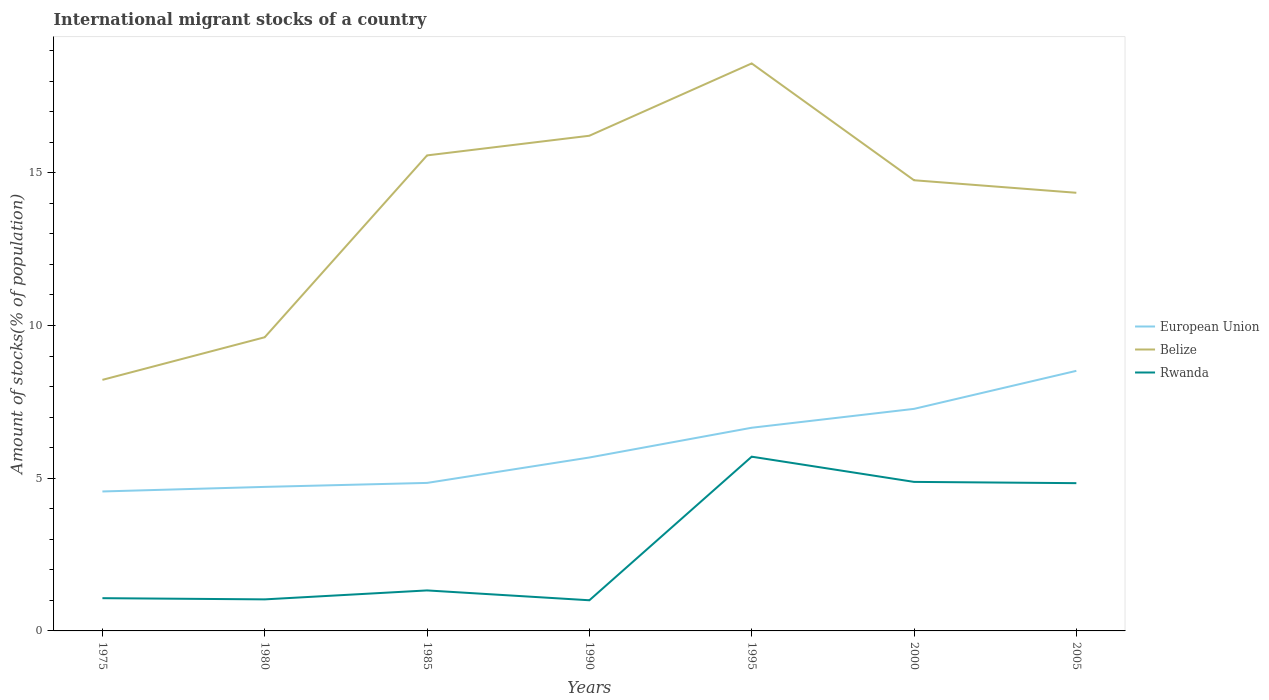How many different coloured lines are there?
Provide a succinct answer. 3. Across all years, what is the maximum amount of stocks in in Rwanda?
Your response must be concise. 1. In which year was the amount of stocks in in Belize maximum?
Provide a short and direct response. 1975. What is the total amount of stocks in in European Union in the graph?
Provide a succinct answer. -0.96. What is the difference between the highest and the second highest amount of stocks in in European Union?
Provide a short and direct response. 3.95. What is the difference between the highest and the lowest amount of stocks in in Belize?
Make the answer very short. 5. Is the amount of stocks in in European Union strictly greater than the amount of stocks in in Rwanda over the years?
Your answer should be very brief. No. How many years are there in the graph?
Make the answer very short. 7. What is the difference between two consecutive major ticks on the Y-axis?
Make the answer very short. 5. Does the graph contain grids?
Your answer should be very brief. No. How are the legend labels stacked?
Your response must be concise. Vertical. What is the title of the graph?
Offer a very short reply. International migrant stocks of a country. Does "Costa Rica" appear as one of the legend labels in the graph?
Your answer should be very brief. No. What is the label or title of the X-axis?
Provide a succinct answer. Years. What is the label or title of the Y-axis?
Offer a very short reply. Amount of stocks(% of population). What is the Amount of stocks(% of population) of European Union in 1975?
Provide a succinct answer. 4.57. What is the Amount of stocks(% of population) in Belize in 1975?
Your response must be concise. 8.22. What is the Amount of stocks(% of population) in Rwanda in 1975?
Offer a very short reply. 1.07. What is the Amount of stocks(% of population) of European Union in 1980?
Keep it short and to the point. 4.72. What is the Amount of stocks(% of population) in Belize in 1980?
Offer a terse response. 9.61. What is the Amount of stocks(% of population) of Rwanda in 1980?
Give a very brief answer. 1.03. What is the Amount of stocks(% of population) of European Union in 1985?
Ensure brevity in your answer.  4.85. What is the Amount of stocks(% of population) in Belize in 1985?
Provide a short and direct response. 15.57. What is the Amount of stocks(% of population) of Rwanda in 1985?
Offer a terse response. 1.33. What is the Amount of stocks(% of population) in European Union in 1990?
Offer a very short reply. 5.68. What is the Amount of stocks(% of population) in Belize in 1990?
Offer a very short reply. 16.21. What is the Amount of stocks(% of population) in Rwanda in 1990?
Keep it short and to the point. 1. What is the Amount of stocks(% of population) in European Union in 1995?
Provide a succinct answer. 6.65. What is the Amount of stocks(% of population) of Belize in 1995?
Provide a succinct answer. 18.58. What is the Amount of stocks(% of population) of Rwanda in 1995?
Offer a terse response. 5.7. What is the Amount of stocks(% of population) in European Union in 2000?
Ensure brevity in your answer.  7.27. What is the Amount of stocks(% of population) of Belize in 2000?
Offer a very short reply. 14.75. What is the Amount of stocks(% of population) in Rwanda in 2000?
Give a very brief answer. 4.88. What is the Amount of stocks(% of population) in European Union in 2005?
Ensure brevity in your answer.  8.51. What is the Amount of stocks(% of population) of Belize in 2005?
Give a very brief answer. 14.34. What is the Amount of stocks(% of population) of Rwanda in 2005?
Your answer should be very brief. 4.84. Across all years, what is the maximum Amount of stocks(% of population) in European Union?
Ensure brevity in your answer.  8.51. Across all years, what is the maximum Amount of stocks(% of population) of Belize?
Give a very brief answer. 18.58. Across all years, what is the maximum Amount of stocks(% of population) of Rwanda?
Offer a terse response. 5.7. Across all years, what is the minimum Amount of stocks(% of population) in European Union?
Your answer should be very brief. 4.57. Across all years, what is the minimum Amount of stocks(% of population) in Belize?
Make the answer very short. 8.22. Across all years, what is the minimum Amount of stocks(% of population) of Rwanda?
Your answer should be very brief. 1. What is the total Amount of stocks(% of population) in European Union in the graph?
Your answer should be compact. 42.24. What is the total Amount of stocks(% of population) in Belize in the graph?
Offer a terse response. 97.29. What is the total Amount of stocks(% of population) of Rwanda in the graph?
Your answer should be compact. 19.85. What is the difference between the Amount of stocks(% of population) of European Union in 1975 and that in 1980?
Offer a very short reply. -0.15. What is the difference between the Amount of stocks(% of population) of Belize in 1975 and that in 1980?
Make the answer very short. -1.4. What is the difference between the Amount of stocks(% of population) in Rwanda in 1975 and that in 1980?
Ensure brevity in your answer.  0.04. What is the difference between the Amount of stocks(% of population) in European Union in 1975 and that in 1985?
Your answer should be very brief. -0.28. What is the difference between the Amount of stocks(% of population) of Belize in 1975 and that in 1985?
Offer a very short reply. -7.35. What is the difference between the Amount of stocks(% of population) of Rwanda in 1975 and that in 1985?
Make the answer very short. -0.25. What is the difference between the Amount of stocks(% of population) in European Union in 1975 and that in 1990?
Your response must be concise. -1.11. What is the difference between the Amount of stocks(% of population) of Belize in 1975 and that in 1990?
Offer a terse response. -7.99. What is the difference between the Amount of stocks(% of population) in Rwanda in 1975 and that in 1990?
Your answer should be compact. 0.07. What is the difference between the Amount of stocks(% of population) of European Union in 1975 and that in 1995?
Make the answer very short. -2.09. What is the difference between the Amount of stocks(% of population) of Belize in 1975 and that in 1995?
Offer a terse response. -10.36. What is the difference between the Amount of stocks(% of population) of Rwanda in 1975 and that in 1995?
Make the answer very short. -4.63. What is the difference between the Amount of stocks(% of population) in European Union in 1975 and that in 2000?
Your answer should be very brief. -2.7. What is the difference between the Amount of stocks(% of population) in Belize in 1975 and that in 2000?
Provide a short and direct response. -6.53. What is the difference between the Amount of stocks(% of population) of Rwanda in 1975 and that in 2000?
Make the answer very short. -3.81. What is the difference between the Amount of stocks(% of population) in European Union in 1975 and that in 2005?
Make the answer very short. -3.95. What is the difference between the Amount of stocks(% of population) of Belize in 1975 and that in 2005?
Offer a terse response. -6.12. What is the difference between the Amount of stocks(% of population) in Rwanda in 1975 and that in 2005?
Make the answer very short. -3.77. What is the difference between the Amount of stocks(% of population) of European Union in 1980 and that in 1985?
Your answer should be very brief. -0.13. What is the difference between the Amount of stocks(% of population) of Belize in 1980 and that in 1985?
Your response must be concise. -5.95. What is the difference between the Amount of stocks(% of population) of Rwanda in 1980 and that in 1985?
Provide a succinct answer. -0.29. What is the difference between the Amount of stocks(% of population) in European Union in 1980 and that in 1990?
Give a very brief answer. -0.96. What is the difference between the Amount of stocks(% of population) of Belize in 1980 and that in 1990?
Provide a short and direct response. -6.6. What is the difference between the Amount of stocks(% of population) of Rwanda in 1980 and that in 1990?
Make the answer very short. 0.03. What is the difference between the Amount of stocks(% of population) of European Union in 1980 and that in 1995?
Keep it short and to the point. -1.94. What is the difference between the Amount of stocks(% of population) in Belize in 1980 and that in 1995?
Make the answer very short. -8.96. What is the difference between the Amount of stocks(% of population) of Rwanda in 1980 and that in 1995?
Your answer should be compact. -4.67. What is the difference between the Amount of stocks(% of population) in European Union in 1980 and that in 2000?
Give a very brief answer. -2.55. What is the difference between the Amount of stocks(% of population) in Belize in 1980 and that in 2000?
Provide a succinct answer. -5.14. What is the difference between the Amount of stocks(% of population) of Rwanda in 1980 and that in 2000?
Give a very brief answer. -3.85. What is the difference between the Amount of stocks(% of population) of European Union in 1980 and that in 2005?
Offer a very short reply. -3.8. What is the difference between the Amount of stocks(% of population) in Belize in 1980 and that in 2005?
Offer a terse response. -4.73. What is the difference between the Amount of stocks(% of population) in Rwanda in 1980 and that in 2005?
Give a very brief answer. -3.8. What is the difference between the Amount of stocks(% of population) of European Union in 1985 and that in 1990?
Provide a short and direct response. -0.83. What is the difference between the Amount of stocks(% of population) in Belize in 1985 and that in 1990?
Your answer should be compact. -0.64. What is the difference between the Amount of stocks(% of population) in Rwanda in 1985 and that in 1990?
Provide a succinct answer. 0.32. What is the difference between the Amount of stocks(% of population) in European Union in 1985 and that in 1995?
Provide a short and direct response. -1.81. What is the difference between the Amount of stocks(% of population) in Belize in 1985 and that in 1995?
Provide a short and direct response. -3.01. What is the difference between the Amount of stocks(% of population) of Rwanda in 1985 and that in 1995?
Your answer should be very brief. -4.38. What is the difference between the Amount of stocks(% of population) of European Union in 1985 and that in 2000?
Provide a succinct answer. -2.42. What is the difference between the Amount of stocks(% of population) in Belize in 1985 and that in 2000?
Make the answer very short. 0.81. What is the difference between the Amount of stocks(% of population) of Rwanda in 1985 and that in 2000?
Keep it short and to the point. -3.55. What is the difference between the Amount of stocks(% of population) of European Union in 1985 and that in 2005?
Your answer should be compact. -3.67. What is the difference between the Amount of stocks(% of population) of Belize in 1985 and that in 2005?
Offer a terse response. 1.22. What is the difference between the Amount of stocks(% of population) of Rwanda in 1985 and that in 2005?
Offer a very short reply. -3.51. What is the difference between the Amount of stocks(% of population) of European Union in 1990 and that in 1995?
Give a very brief answer. -0.97. What is the difference between the Amount of stocks(% of population) of Belize in 1990 and that in 1995?
Give a very brief answer. -2.37. What is the difference between the Amount of stocks(% of population) in Rwanda in 1990 and that in 1995?
Offer a very short reply. -4.7. What is the difference between the Amount of stocks(% of population) of European Union in 1990 and that in 2000?
Offer a terse response. -1.59. What is the difference between the Amount of stocks(% of population) of Belize in 1990 and that in 2000?
Provide a succinct answer. 1.46. What is the difference between the Amount of stocks(% of population) in Rwanda in 1990 and that in 2000?
Provide a succinct answer. -3.88. What is the difference between the Amount of stocks(% of population) of European Union in 1990 and that in 2005?
Your response must be concise. -2.84. What is the difference between the Amount of stocks(% of population) of Belize in 1990 and that in 2005?
Your answer should be compact. 1.87. What is the difference between the Amount of stocks(% of population) of Rwanda in 1990 and that in 2005?
Provide a succinct answer. -3.83. What is the difference between the Amount of stocks(% of population) of European Union in 1995 and that in 2000?
Keep it short and to the point. -0.62. What is the difference between the Amount of stocks(% of population) of Belize in 1995 and that in 2000?
Make the answer very short. 3.82. What is the difference between the Amount of stocks(% of population) in Rwanda in 1995 and that in 2000?
Keep it short and to the point. 0.83. What is the difference between the Amount of stocks(% of population) in European Union in 1995 and that in 2005?
Your response must be concise. -1.86. What is the difference between the Amount of stocks(% of population) in Belize in 1995 and that in 2005?
Ensure brevity in your answer.  4.24. What is the difference between the Amount of stocks(% of population) of Rwanda in 1995 and that in 2005?
Make the answer very short. 0.87. What is the difference between the Amount of stocks(% of population) in European Union in 2000 and that in 2005?
Your answer should be very brief. -1.25. What is the difference between the Amount of stocks(% of population) in Belize in 2000 and that in 2005?
Make the answer very short. 0.41. What is the difference between the Amount of stocks(% of population) in Rwanda in 2000 and that in 2005?
Keep it short and to the point. 0.04. What is the difference between the Amount of stocks(% of population) in European Union in 1975 and the Amount of stocks(% of population) in Belize in 1980?
Provide a short and direct response. -5.05. What is the difference between the Amount of stocks(% of population) in European Union in 1975 and the Amount of stocks(% of population) in Rwanda in 1980?
Give a very brief answer. 3.53. What is the difference between the Amount of stocks(% of population) in Belize in 1975 and the Amount of stocks(% of population) in Rwanda in 1980?
Offer a very short reply. 7.19. What is the difference between the Amount of stocks(% of population) in European Union in 1975 and the Amount of stocks(% of population) in Belize in 1985?
Your answer should be compact. -11. What is the difference between the Amount of stocks(% of population) in European Union in 1975 and the Amount of stocks(% of population) in Rwanda in 1985?
Make the answer very short. 3.24. What is the difference between the Amount of stocks(% of population) in Belize in 1975 and the Amount of stocks(% of population) in Rwanda in 1985?
Offer a very short reply. 6.89. What is the difference between the Amount of stocks(% of population) in European Union in 1975 and the Amount of stocks(% of population) in Belize in 1990?
Your response must be concise. -11.65. What is the difference between the Amount of stocks(% of population) in European Union in 1975 and the Amount of stocks(% of population) in Rwanda in 1990?
Your answer should be very brief. 3.56. What is the difference between the Amount of stocks(% of population) of Belize in 1975 and the Amount of stocks(% of population) of Rwanda in 1990?
Your answer should be compact. 7.22. What is the difference between the Amount of stocks(% of population) in European Union in 1975 and the Amount of stocks(% of population) in Belize in 1995?
Provide a succinct answer. -14.01. What is the difference between the Amount of stocks(% of population) in European Union in 1975 and the Amount of stocks(% of population) in Rwanda in 1995?
Give a very brief answer. -1.14. What is the difference between the Amount of stocks(% of population) in Belize in 1975 and the Amount of stocks(% of population) in Rwanda in 1995?
Ensure brevity in your answer.  2.51. What is the difference between the Amount of stocks(% of population) of European Union in 1975 and the Amount of stocks(% of population) of Belize in 2000?
Your answer should be compact. -10.19. What is the difference between the Amount of stocks(% of population) in European Union in 1975 and the Amount of stocks(% of population) in Rwanda in 2000?
Your answer should be very brief. -0.31. What is the difference between the Amount of stocks(% of population) in Belize in 1975 and the Amount of stocks(% of population) in Rwanda in 2000?
Make the answer very short. 3.34. What is the difference between the Amount of stocks(% of population) in European Union in 1975 and the Amount of stocks(% of population) in Belize in 2005?
Provide a short and direct response. -9.78. What is the difference between the Amount of stocks(% of population) of European Union in 1975 and the Amount of stocks(% of population) of Rwanda in 2005?
Make the answer very short. -0.27. What is the difference between the Amount of stocks(% of population) in Belize in 1975 and the Amount of stocks(% of population) in Rwanda in 2005?
Provide a succinct answer. 3.38. What is the difference between the Amount of stocks(% of population) in European Union in 1980 and the Amount of stocks(% of population) in Belize in 1985?
Your response must be concise. -10.85. What is the difference between the Amount of stocks(% of population) of European Union in 1980 and the Amount of stocks(% of population) of Rwanda in 1985?
Your response must be concise. 3.39. What is the difference between the Amount of stocks(% of population) in Belize in 1980 and the Amount of stocks(% of population) in Rwanda in 1985?
Your response must be concise. 8.29. What is the difference between the Amount of stocks(% of population) in European Union in 1980 and the Amount of stocks(% of population) in Belize in 1990?
Provide a short and direct response. -11.5. What is the difference between the Amount of stocks(% of population) in European Union in 1980 and the Amount of stocks(% of population) in Rwanda in 1990?
Provide a succinct answer. 3.71. What is the difference between the Amount of stocks(% of population) in Belize in 1980 and the Amount of stocks(% of population) in Rwanda in 1990?
Offer a very short reply. 8.61. What is the difference between the Amount of stocks(% of population) in European Union in 1980 and the Amount of stocks(% of population) in Belize in 1995?
Give a very brief answer. -13.86. What is the difference between the Amount of stocks(% of population) of European Union in 1980 and the Amount of stocks(% of population) of Rwanda in 1995?
Provide a short and direct response. -0.99. What is the difference between the Amount of stocks(% of population) in Belize in 1980 and the Amount of stocks(% of population) in Rwanda in 1995?
Your answer should be compact. 3.91. What is the difference between the Amount of stocks(% of population) in European Union in 1980 and the Amount of stocks(% of population) in Belize in 2000?
Provide a short and direct response. -10.04. What is the difference between the Amount of stocks(% of population) of European Union in 1980 and the Amount of stocks(% of population) of Rwanda in 2000?
Offer a terse response. -0.16. What is the difference between the Amount of stocks(% of population) of Belize in 1980 and the Amount of stocks(% of population) of Rwanda in 2000?
Give a very brief answer. 4.74. What is the difference between the Amount of stocks(% of population) of European Union in 1980 and the Amount of stocks(% of population) of Belize in 2005?
Offer a terse response. -9.63. What is the difference between the Amount of stocks(% of population) of European Union in 1980 and the Amount of stocks(% of population) of Rwanda in 2005?
Your response must be concise. -0.12. What is the difference between the Amount of stocks(% of population) of Belize in 1980 and the Amount of stocks(% of population) of Rwanda in 2005?
Offer a very short reply. 4.78. What is the difference between the Amount of stocks(% of population) of European Union in 1985 and the Amount of stocks(% of population) of Belize in 1990?
Ensure brevity in your answer.  -11.37. What is the difference between the Amount of stocks(% of population) of European Union in 1985 and the Amount of stocks(% of population) of Rwanda in 1990?
Make the answer very short. 3.84. What is the difference between the Amount of stocks(% of population) of Belize in 1985 and the Amount of stocks(% of population) of Rwanda in 1990?
Your answer should be very brief. 14.56. What is the difference between the Amount of stocks(% of population) of European Union in 1985 and the Amount of stocks(% of population) of Belize in 1995?
Offer a very short reply. -13.73. What is the difference between the Amount of stocks(% of population) in European Union in 1985 and the Amount of stocks(% of population) in Rwanda in 1995?
Ensure brevity in your answer.  -0.86. What is the difference between the Amount of stocks(% of population) in Belize in 1985 and the Amount of stocks(% of population) in Rwanda in 1995?
Your answer should be compact. 9.86. What is the difference between the Amount of stocks(% of population) in European Union in 1985 and the Amount of stocks(% of population) in Belize in 2000?
Provide a succinct answer. -9.91. What is the difference between the Amount of stocks(% of population) in European Union in 1985 and the Amount of stocks(% of population) in Rwanda in 2000?
Offer a very short reply. -0.03. What is the difference between the Amount of stocks(% of population) in Belize in 1985 and the Amount of stocks(% of population) in Rwanda in 2000?
Offer a terse response. 10.69. What is the difference between the Amount of stocks(% of population) in European Union in 1985 and the Amount of stocks(% of population) in Belize in 2005?
Your answer should be compact. -9.5. What is the difference between the Amount of stocks(% of population) of European Union in 1985 and the Amount of stocks(% of population) of Rwanda in 2005?
Give a very brief answer. 0.01. What is the difference between the Amount of stocks(% of population) of Belize in 1985 and the Amount of stocks(% of population) of Rwanda in 2005?
Provide a short and direct response. 10.73. What is the difference between the Amount of stocks(% of population) in European Union in 1990 and the Amount of stocks(% of population) in Belize in 1995?
Make the answer very short. -12.9. What is the difference between the Amount of stocks(% of population) of European Union in 1990 and the Amount of stocks(% of population) of Rwanda in 1995?
Make the answer very short. -0.03. What is the difference between the Amount of stocks(% of population) of Belize in 1990 and the Amount of stocks(% of population) of Rwanda in 1995?
Provide a succinct answer. 10.51. What is the difference between the Amount of stocks(% of population) of European Union in 1990 and the Amount of stocks(% of population) of Belize in 2000?
Provide a short and direct response. -9.08. What is the difference between the Amount of stocks(% of population) in European Union in 1990 and the Amount of stocks(% of population) in Rwanda in 2000?
Provide a short and direct response. 0.8. What is the difference between the Amount of stocks(% of population) of Belize in 1990 and the Amount of stocks(% of population) of Rwanda in 2000?
Give a very brief answer. 11.33. What is the difference between the Amount of stocks(% of population) in European Union in 1990 and the Amount of stocks(% of population) in Belize in 2005?
Give a very brief answer. -8.67. What is the difference between the Amount of stocks(% of population) of European Union in 1990 and the Amount of stocks(% of population) of Rwanda in 2005?
Your answer should be very brief. 0.84. What is the difference between the Amount of stocks(% of population) in Belize in 1990 and the Amount of stocks(% of population) in Rwanda in 2005?
Ensure brevity in your answer.  11.37. What is the difference between the Amount of stocks(% of population) in European Union in 1995 and the Amount of stocks(% of population) in Belize in 2000?
Provide a succinct answer. -8.1. What is the difference between the Amount of stocks(% of population) in European Union in 1995 and the Amount of stocks(% of population) in Rwanda in 2000?
Your response must be concise. 1.77. What is the difference between the Amount of stocks(% of population) of Belize in 1995 and the Amount of stocks(% of population) of Rwanda in 2000?
Offer a very short reply. 13.7. What is the difference between the Amount of stocks(% of population) in European Union in 1995 and the Amount of stocks(% of population) in Belize in 2005?
Give a very brief answer. -7.69. What is the difference between the Amount of stocks(% of population) in European Union in 1995 and the Amount of stocks(% of population) in Rwanda in 2005?
Offer a very short reply. 1.81. What is the difference between the Amount of stocks(% of population) in Belize in 1995 and the Amount of stocks(% of population) in Rwanda in 2005?
Provide a succinct answer. 13.74. What is the difference between the Amount of stocks(% of population) in European Union in 2000 and the Amount of stocks(% of population) in Belize in 2005?
Provide a short and direct response. -7.07. What is the difference between the Amount of stocks(% of population) of European Union in 2000 and the Amount of stocks(% of population) of Rwanda in 2005?
Your answer should be compact. 2.43. What is the difference between the Amount of stocks(% of population) in Belize in 2000 and the Amount of stocks(% of population) in Rwanda in 2005?
Give a very brief answer. 9.92. What is the average Amount of stocks(% of population) in European Union per year?
Ensure brevity in your answer.  6.03. What is the average Amount of stocks(% of population) in Belize per year?
Provide a short and direct response. 13.9. What is the average Amount of stocks(% of population) in Rwanda per year?
Give a very brief answer. 2.84. In the year 1975, what is the difference between the Amount of stocks(% of population) in European Union and Amount of stocks(% of population) in Belize?
Provide a short and direct response. -3.65. In the year 1975, what is the difference between the Amount of stocks(% of population) of European Union and Amount of stocks(% of population) of Rwanda?
Offer a terse response. 3.49. In the year 1975, what is the difference between the Amount of stocks(% of population) of Belize and Amount of stocks(% of population) of Rwanda?
Ensure brevity in your answer.  7.15. In the year 1980, what is the difference between the Amount of stocks(% of population) in European Union and Amount of stocks(% of population) in Belize?
Offer a very short reply. -4.9. In the year 1980, what is the difference between the Amount of stocks(% of population) of European Union and Amount of stocks(% of population) of Rwanda?
Your answer should be compact. 3.68. In the year 1980, what is the difference between the Amount of stocks(% of population) of Belize and Amount of stocks(% of population) of Rwanda?
Provide a succinct answer. 8.58. In the year 1985, what is the difference between the Amount of stocks(% of population) of European Union and Amount of stocks(% of population) of Belize?
Keep it short and to the point. -10.72. In the year 1985, what is the difference between the Amount of stocks(% of population) in European Union and Amount of stocks(% of population) in Rwanda?
Your response must be concise. 3.52. In the year 1985, what is the difference between the Amount of stocks(% of population) of Belize and Amount of stocks(% of population) of Rwanda?
Give a very brief answer. 14.24. In the year 1990, what is the difference between the Amount of stocks(% of population) in European Union and Amount of stocks(% of population) in Belize?
Offer a very short reply. -10.53. In the year 1990, what is the difference between the Amount of stocks(% of population) in European Union and Amount of stocks(% of population) in Rwanda?
Give a very brief answer. 4.67. In the year 1990, what is the difference between the Amount of stocks(% of population) in Belize and Amount of stocks(% of population) in Rwanda?
Offer a very short reply. 15.21. In the year 1995, what is the difference between the Amount of stocks(% of population) in European Union and Amount of stocks(% of population) in Belize?
Give a very brief answer. -11.93. In the year 1995, what is the difference between the Amount of stocks(% of population) of European Union and Amount of stocks(% of population) of Rwanda?
Your answer should be very brief. 0.95. In the year 1995, what is the difference between the Amount of stocks(% of population) in Belize and Amount of stocks(% of population) in Rwanda?
Make the answer very short. 12.87. In the year 2000, what is the difference between the Amount of stocks(% of population) in European Union and Amount of stocks(% of population) in Belize?
Offer a terse response. -7.48. In the year 2000, what is the difference between the Amount of stocks(% of population) of European Union and Amount of stocks(% of population) of Rwanda?
Your answer should be compact. 2.39. In the year 2000, what is the difference between the Amount of stocks(% of population) of Belize and Amount of stocks(% of population) of Rwanda?
Make the answer very short. 9.87. In the year 2005, what is the difference between the Amount of stocks(% of population) of European Union and Amount of stocks(% of population) of Belize?
Your response must be concise. -5.83. In the year 2005, what is the difference between the Amount of stocks(% of population) of European Union and Amount of stocks(% of population) of Rwanda?
Provide a succinct answer. 3.68. In the year 2005, what is the difference between the Amount of stocks(% of population) in Belize and Amount of stocks(% of population) in Rwanda?
Your answer should be very brief. 9.51. What is the ratio of the Amount of stocks(% of population) in European Union in 1975 to that in 1980?
Give a very brief answer. 0.97. What is the ratio of the Amount of stocks(% of population) of Belize in 1975 to that in 1980?
Your answer should be very brief. 0.85. What is the ratio of the Amount of stocks(% of population) of Rwanda in 1975 to that in 1980?
Your answer should be very brief. 1.04. What is the ratio of the Amount of stocks(% of population) in European Union in 1975 to that in 1985?
Keep it short and to the point. 0.94. What is the ratio of the Amount of stocks(% of population) of Belize in 1975 to that in 1985?
Give a very brief answer. 0.53. What is the ratio of the Amount of stocks(% of population) in Rwanda in 1975 to that in 1985?
Make the answer very short. 0.81. What is the ratio of the Amount of stocks(% of population) in European Union in 1975 to that in 1990?
Provide a short and direct response. 0.8. What is the ratio of the Amount of stocks(% of population) of Belize in 1975 to that in 1990?
Make the answer very short. 0.51. What is the ratio of the Amount of stocks(% of population) of Rwanda in 1975 to that in 1990?
Ensure brevity in your answer.  1.07. What is the ratio of the Amount of stocks(% of population) of European Union in 1975 to that in 1995?
Provide a succinct answer. 0.69. What is the ratio of the Amount of stocks(% of population) of Belize in 1975 to that in 1995?
Give a very brief answer. 0.44. What is the ratio of the Amount of stocks(% of population) of Rwanda in 1975 to that in 1995?
Ensure brevity in your answer.  0.19. What is the ratio of the Amount of stocks(% of population) in European Union in 1975 to that in 2000?
Provide a short and direct response. 0.63. What is the ratio of the Amount of stocks(% of population) in Belize in 1975 to that in 2000?
Offer a terse response. 0.56. What is the ratio of the Amount of stocks(% of population) of Rwanda in 1975 to that in 2000?
Your answer should be compact. 0.22. What is the ratio of the Amount of stocks(% of population) in European Union in 1975 to that in 2005?
Offer a terse response. 0.54. What is the ratio of the Amount of stocks(% of population) of Belize in 1975 to that in 2005?
Your answer should be very brief. 0.57. What is the ratio of the Amount of stocks(% of population) of Rwanda in 1975 to that in 2005?
Provide a succinct answer. 0.22. What is the ratio of the Amount of stocks(% of population) in European Union in 1980 to that in 1985?
Keep it short and to the point. 0.97. What is the ratio of the Amount of stocks(% of population) in Belize in 1980 to that in 1985?
Your answer should be compact. 0.62. What is the ratio of the Amount of stocks(% of population) in Rwanda in 1980 to that in 1985?
Offer a terse response. 0.78. What is the ratio of the Amount of stocks(% of population) of European Union in 1980 to that in 1990?
Ensure brevity in your answer.  0.83. What is the ratio of the Amount of stocks(% of population) in Belize in 1980 to that in 1990?
Give a very brief answer. 0.59. What is the ratio of the Amount of stocks(% of population) of Rwanda in 1980 to that in 1990?
Your answer should be compact. 1.03. What is the ratio of the Amount of stocks(% of population) in European Union in 1980 to that in 1995?
Offer a very short reply. 0.71. What is the ratio of the Amount of stocks(% of population) in Belize in 1980 to that in 1995?
Ensure brevity in your answer.  0.52. What is the ratio of the Amount of stocks(% of population) of Rwanda in 1980 to that in 1995?
Give a very brief answer. 0.18. What is the ratio of the Amount of stocks(% of population) in European Union in 1980 to that in 2000?
Provide a short and direct response. 0.65. What is the ratio of the Amount of stocks(% of population) in Belize in 1980 to that in 2000?
Make the answer very short. 0.65. What is the ratio of the Amount of stocks(% of population) of Rwanda in 1980 to that in 2000?
Your answer should be very brief. 0.21. What is the ratio of the Amount of stocks(% of population) of European Union in 1980 to that in 2005?
Offer a terse response. 0.55. What is the ratio of the Amount of stocks(% of population) in Belize in 1980 to that in 2005?
Make the answer very short. 0.67. What is the ratio of the Amount of stocks(% of population) of Rwanda in 1980 to that in 2005?
Make the answer very short. 0.21. What is the ratio of the Amount of stocks(% of population) in European Union in 1985 to that in 1990?
Your answer should be very brief. 0.85. What is the ratio of the Amount of stocks(% of population) of Belize in 1985 to that in 1990?
Your answer should be compact. 0.96. What is the ratio of the Amount of stocks(% of population) in Rwanda in 1985 to that in 1990?
Provide a succinct answer. 1.32. What is the ratio of the Amount of stocks(% of population) of European Union in 1985 to that in 1995?
Your answer should be compact. 0.73. What is the ratio of the Amount of stocks(% of population) in Belize in 1985 to that in 1995?
Your response must be concise. 0.84. What is the ratio of the Amount of stocks(% of population) in Rwanda in 1985 to that in 1995?
Your response must be concise. 0.23. What is the ratio of the Amount of stocks(% of population) in European Union in 1985 to that in 2000?
Make the answer very short. 0.67. What is the ratio of the Amount of stocks(% of population) in Belize in 1985 to that in 2000?
Provide a succinct answer. 1.06. What is the ratio of the Amount of stocks(% of population) in Rwanda in 1985 to that in 2000?
Offer a very short reply. 0.27. What is the ratio of the Amount of stocks(% of population) of European Union in 1985 to that in 2005?
Give a very brief answer. 0.57. What is the ratio of the Amount of stocks(% of population) of Belize in 1985 to that in 2005?
Your answer should be very brief. 1.09. What is the ratio of the Amount of stocks(% of population) of Rwanda in 1985 to that in 2005?
Provide a succinct answer. 0.27. What is the ratio of the Amount of stocks(% of population) of European Union in 1990 to that in 1995?
Provide a short and direct response. 0.85. What is the ratio of the Amount of stocks(% of population) in Belize in 1990 to that in 1995?
Your answer should be compact. 0.87. What is the ratio of the Amount of stocks(% of population) of Rwanda in 1990 to that in 1995?
Provide a short and direct response. 0.18. What is the ratio of the Amount of stocks(% of population) of European Union in 1990 to that in 2000?
Make the answer very short. 0.78. What is the ratio of the Amount of stocks(% of population) in Belize in 1990 to that in 2000?
Your response must be concise. 1.1. What is the ratio of the Amount of stocks(% of population) in Rwanda in 1990 to that in 2000?
Your answer should be very brief. 0.21. What is the ratio of the Amount of stocks(% of population) in European Union in 1990 to that in 2005?
Your answer should be compact. 0.67. What is the ratio of the Amount of stocks(% of population) of Belize in 1990 to that in 2005?
Offer a very short reply. 1.13. What is the ratio of the Amount of stocks(% of population) in Rwanda in 1990 to that in 2005?
Offer a terse response. 0.21. What is the ratio of the Amount of stocks(% of population) of European Union in 1995 to that in 2000?
Give a very brief answer. 0.92. What is the ratio of the Amount of stocks(% of population) in Belize in 1995 to that in 2000?
Provide a short and direct response. 1.26. What is the ratio of the Amount of stocks(% of population) of Rwanda in 1995 to that in 2000?
Your response must be concise. 1.17. What is the ratio of the Amount of stocks(% of population) in European Union in 1995 to that in 2005?
Offer a terse response. 0.78. What is the ratio of the Amount of stocks(% of population) in Belize in 1995 to that in 2005?
Keep it short and to the point. 1.3. What is the ratio of the Amount of stocks(% of population) in Rwanda in 1995 to that in 2005?
Keep it short and to the point. 1.18. What is the ratio of the Amount of stocks(% of population) in European Union in 2000 to that in 2005?
Your response must be concise. 0.85. What is the ratio of the Amount of stocks(% of population) of Belize in 2000 to that in 2005?
Provide a succinct answer. 1.03. What is the ratio of the Amount of stocks(% of population) in Rwanda in 2000 to that in 2005?
Keep it short and to the point. 1.01. What is the difference between the highest and the second highest Amount of stocks(% of population) of European Union?
Give a very brief answer. 1.25. What is the difference between the highest and the second highest Amount of stocks(% of population) in Belize?
Ensure brevity in your answer.  2.37. What is the difference between the highest and the second highest Amount of stocks(% of population) of Rwanda?
Ensure brevity in your answer.  0.83. What is the difference between the highest and the lowest Amount of stocks(% of population) in European Union?
Your response must be concise. 3.95. What is the difference between the highest and the lowest Amount of stocks(% of population) in Belize?
Your answer should be very brief. 10.36. What is the difference between the highest and the lowest Amount of stocks(% of population) in Rwanda?
Offer a terse response. 4.7. 